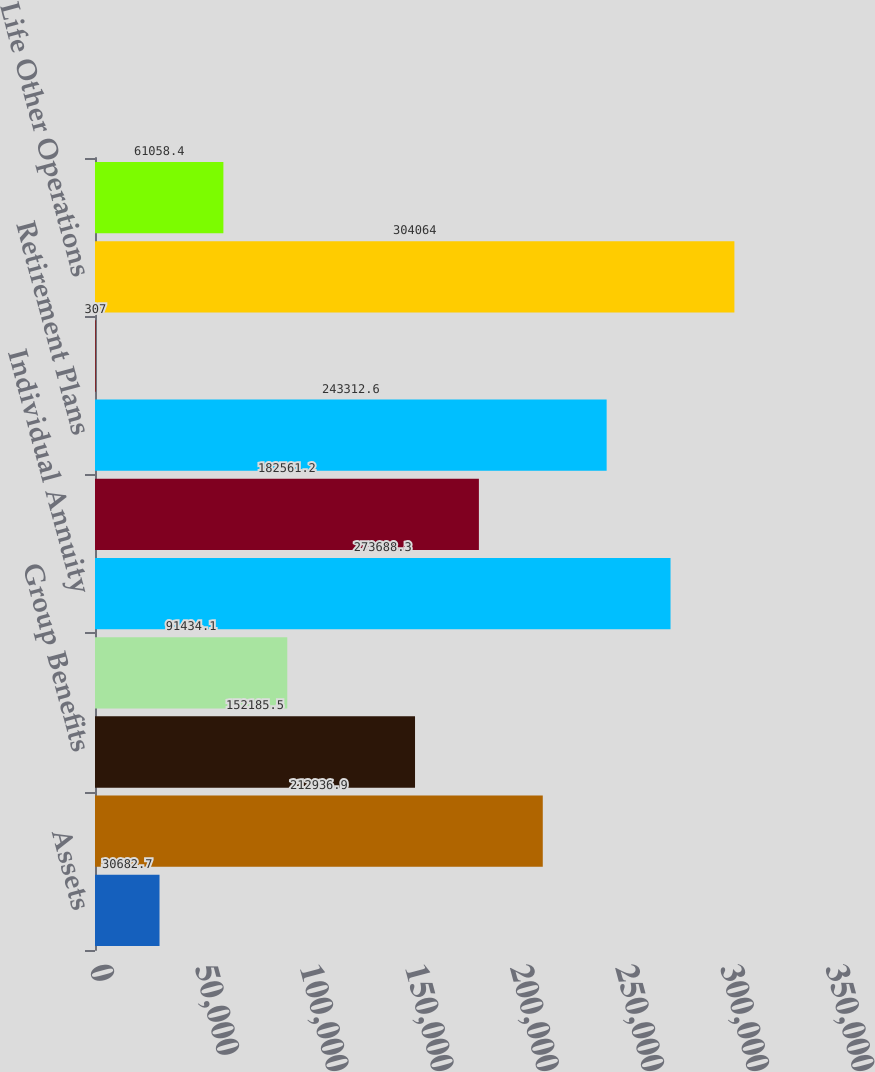Convert chart to OTSL. <chart><loc_0><loc_0><loc_500><loc_500><bar_chart><fcel>Assets<fcel>Property & Casualty Commercial<fcel>Group Benefits<fcel>Consumer Markets<fcel>Individual Annuity<fcel>Individual Life<fcel>Retirement Plans<fcel>Mutual Funds<fcel>Life Other Operations<fcel>Property & Casualty Other<nl><fcel>30682.7<fcel>212937<fcel>152186<fcel>91434.1<fcel>273688<fcel>182561<fcel>243313<fcel>307<fcel>304064<fcel>61058.4<nl></chart> 